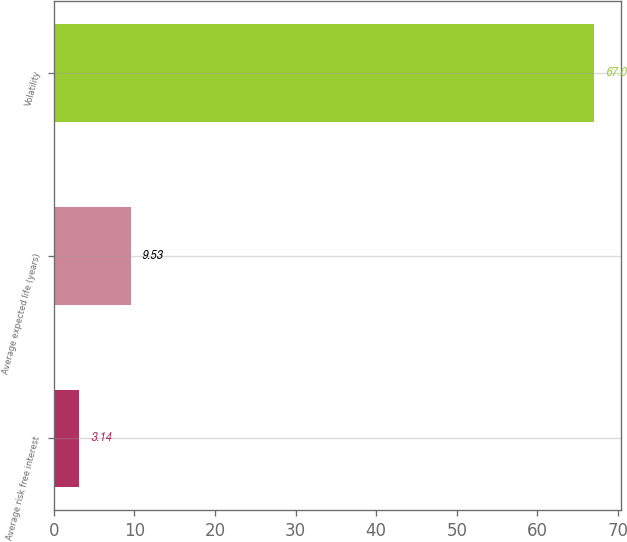<chart> <loc_0><loc_0><loc_500><loc_500><bar_chart><fcel>Average risk free interest<fcel>Average expected life (years)<fcel>Volatility<nl><fcel>3.14<fcel>9.53<fcel>67<nl></chart> 